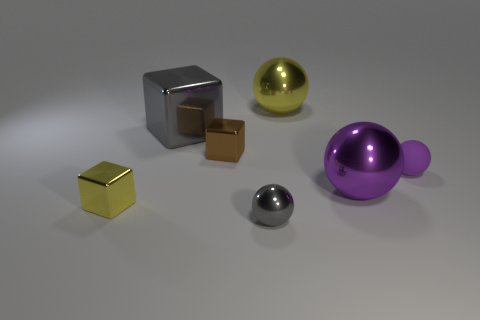Add 1 gray rubber cylinders. How many objects exist? 8 Subtract all balls. How many objects are left? 3 Subtract 0 green cubes. How many objects are left? 7 Subtract all green cylinders. Subtract all tiny yellow blocks. How many objects are left? 6 Add 7 small yellow objects. How many small yellow objects are left? 8 Add 3 big gray shiny cubes. How many big gray shiny cubes exist? 4 